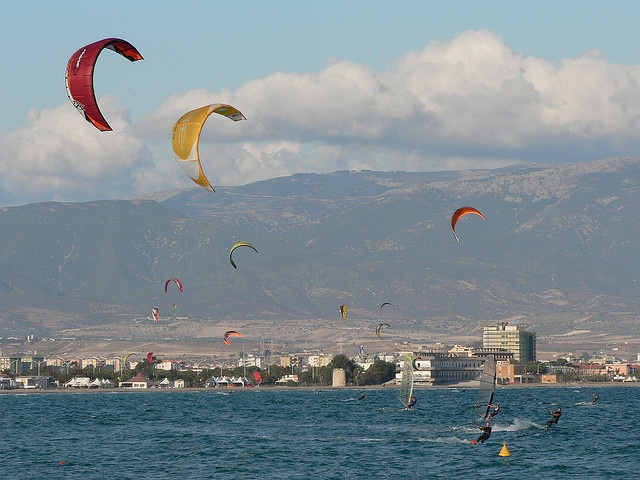Describe the objects in this image and their specific colors. I can see kite in lightblue, brown, maroon, and black tones, kite in lightblue, darkgray, orange, and olive tones, kite in lightblue, gray, and darkgray tones, kite in lightblue, gray, and black tones, and kite in lightblue, brown, maroon, and gray tones in this image. 